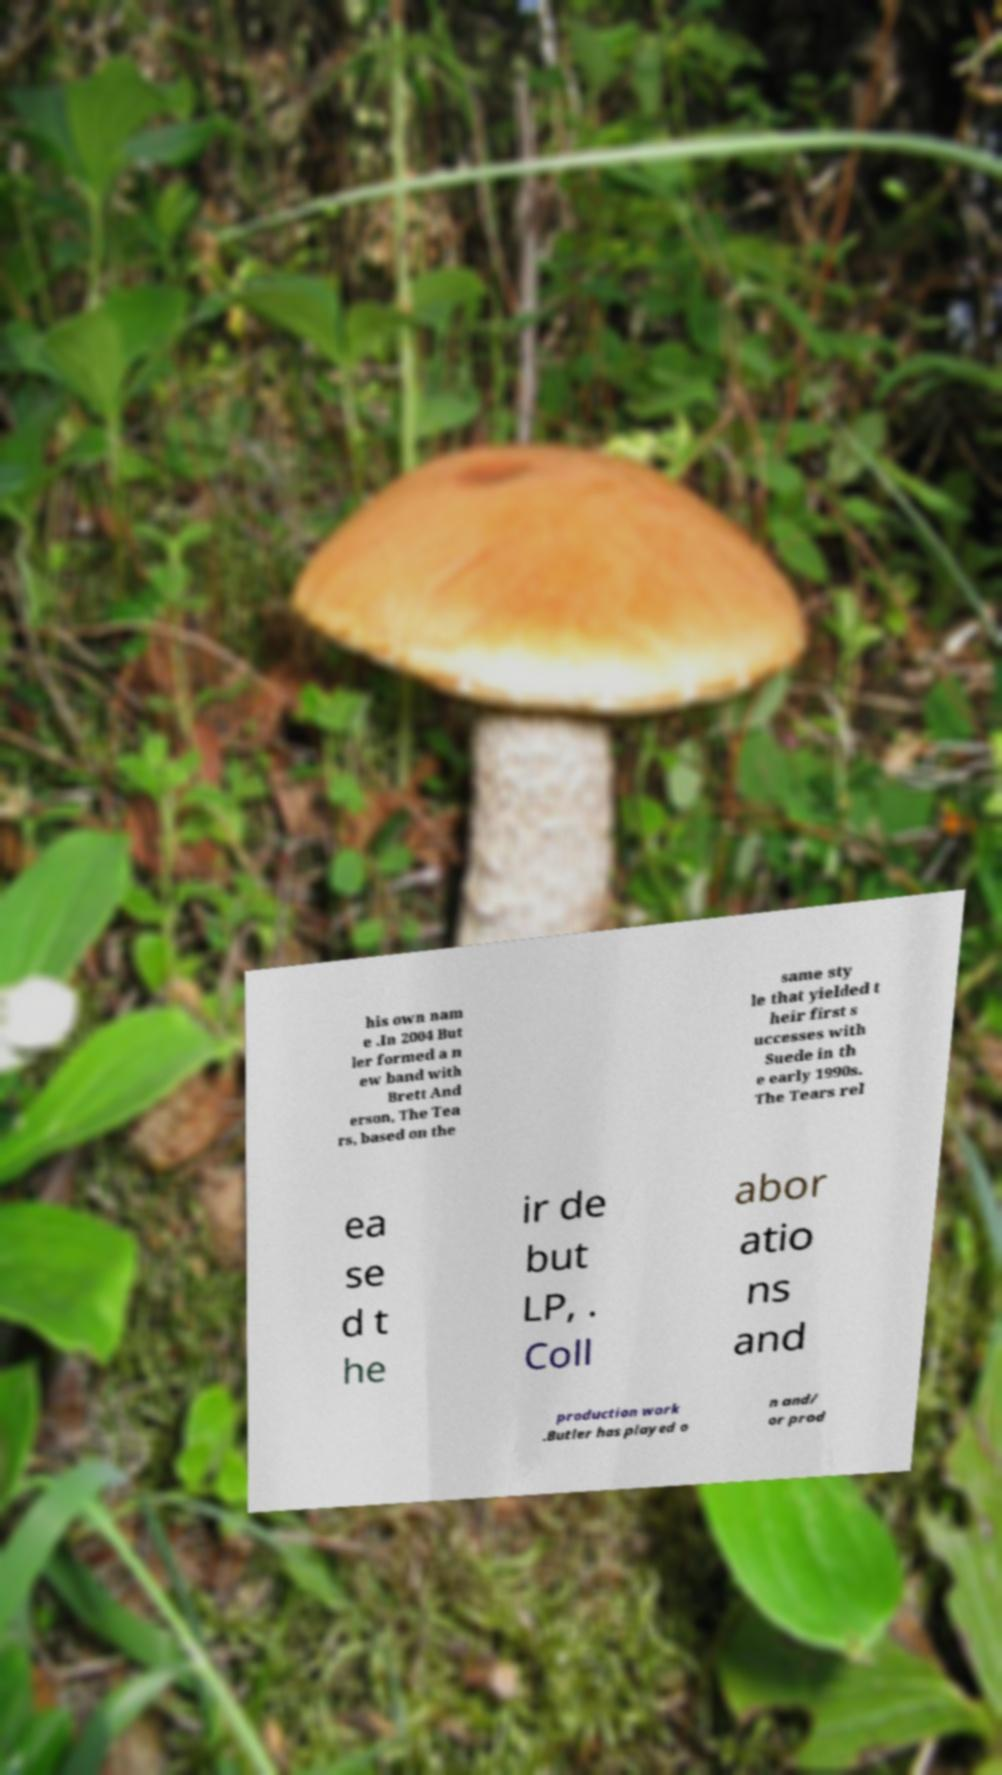Please read and relay the text visible in this image. What does it say? his own nam e .In 2004 But ler formed a n ew band with Brett And erson, The Tea rs, based on the same sty le that yielded t heir first s uccesses with Suede in th e early 1990s. The Tears rel ea se d t he ir de but LP, . Coll abor atio ns and production work .Butler has played o n and/ or prod 